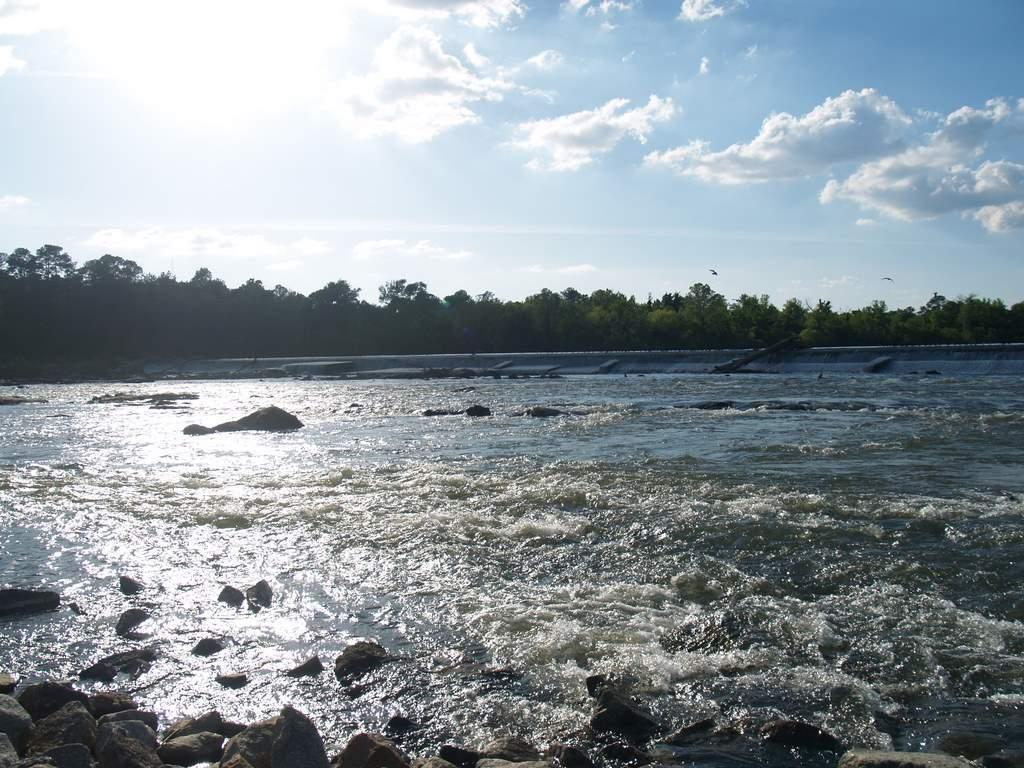What is the primary element visible in the image? There is water in the image. What other objects can be seen in the water? There are rocks in the image. What can be seen in the background of the image? There are trees and the sky visible in the background of the image. What is the condition of the sky in the image? Clouds are present in the sky. What type of theory is being discussed by the rocks in the image? There are no rocks discussing any theories in the image; they are simply objects within the water. 